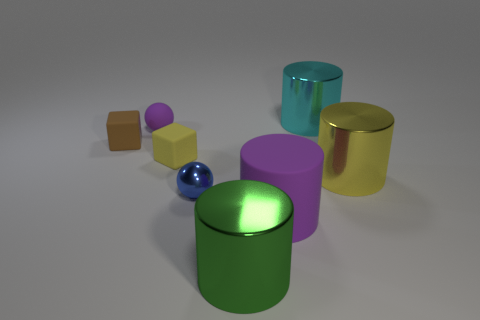What size is the object that is both on the left side of the purple matte cylinder and in front of the blue shiny ball?
Your answer should be compact. Large. There is a thing that is the same color as the small matte ball; what is its material?
Offer a terse response. Rubber. Are there an equal number of large yellow shiny things left of the purple rubber sphere and small yellow matte blocks?
Keep it short and to the point. No. Is the size of the purple matte sphere the same as the blue metallic thing?
Offer a terse response. Yes. What color is the large cylinder that is both on the right side of the green cylinder and on the left side of the cyan cylinder?
Your response must be concise. Purple. What is the material of the big cylinder that is to the right of the big shiny object that is behind the large yellow metallic thing?
Your answer should be compact. Metal. What size is the purple rubber thing that is the same shape as the green object?
Provide a succinct answer. Large. Does the metal thing to the left of the green object have the same color as the matte ball?
Your answer should be compact. No. Is the number of purple things less than the number of gray things?
Give a very brief answer. No. How many other objects are there of the same color as the rubber cylinder?
Provide a short and direct response. 1. 